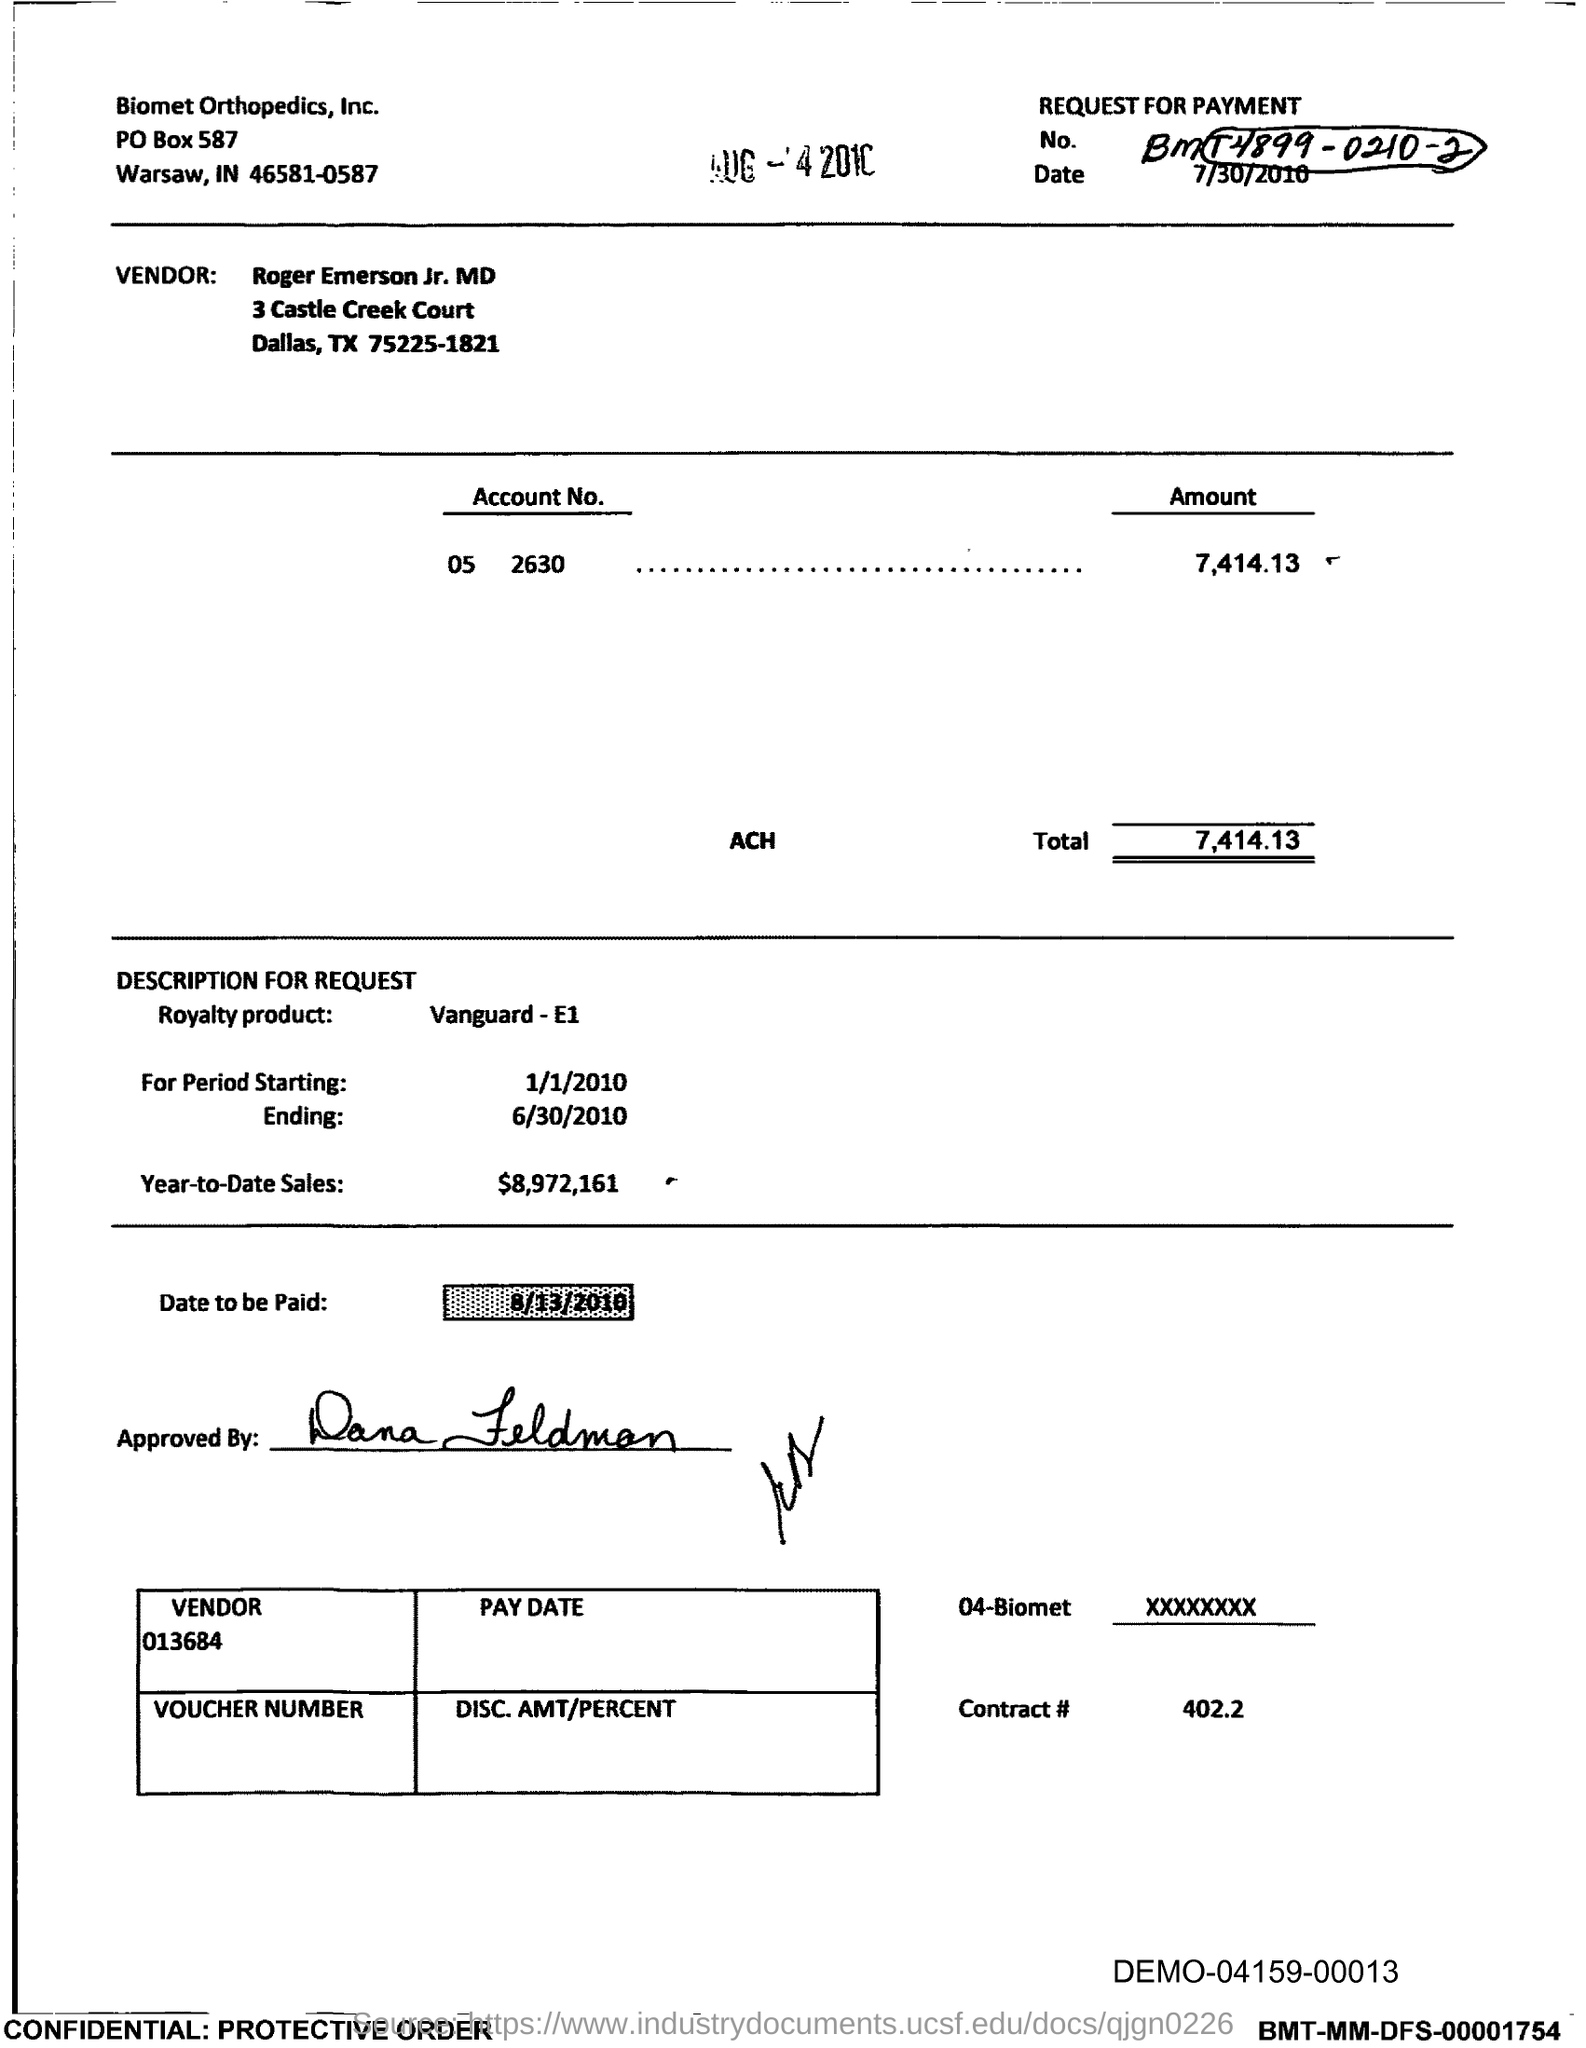Indicate a few pertinent items in this graphic. The total is 7,414.13. The Contract # Number is 402.2.. 